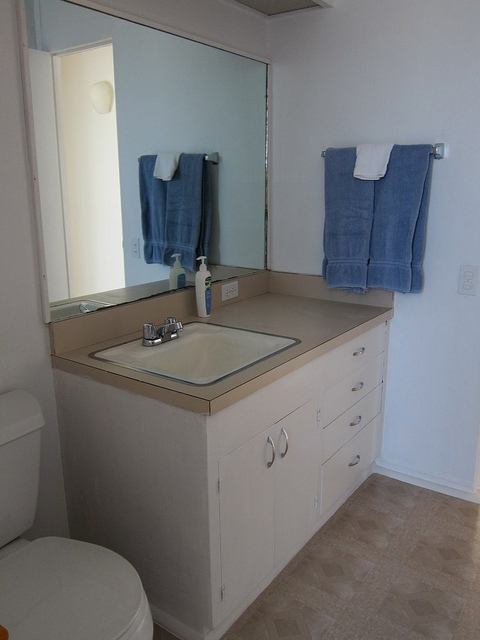<image>Why painted white color? I don't know why it was painted white. The reason can be to make it look clean or simply due to style preferences. What is the black object on the counter? There is no black object on the counter in the image. Why painted white color? I don't know why it is painted white. It can be for various reasons such as to look clean, to match the surroundings, or simply because the person liked it. What is the black object on the counter? I don't know what the black object on the counter is. There doesn't seem to be one in the image. 